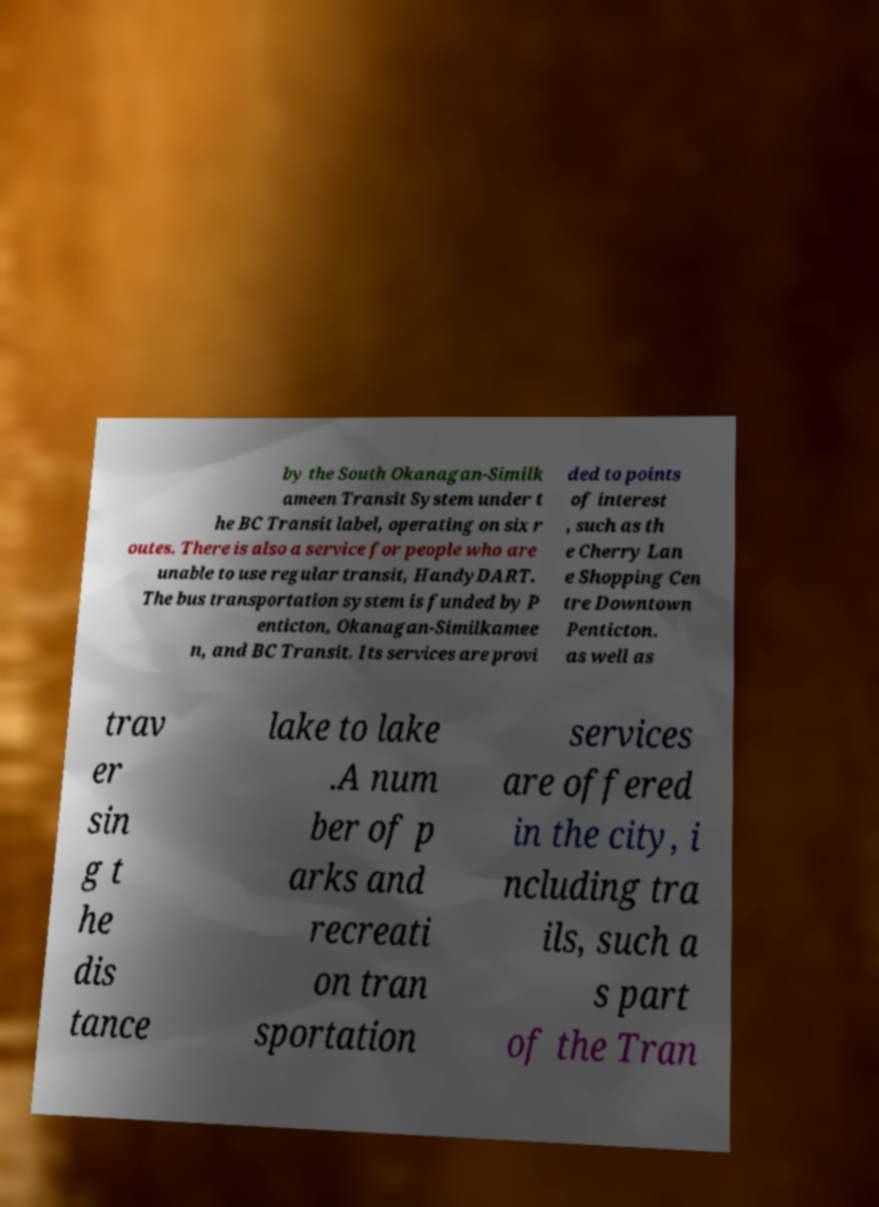Please read and relay the text visible in this image. What does it say? by the South Okanagan-Similk ameen Transit System under t he BC Transit label, operating on six r outes. There is also a service for people who are unable to use regular transit, HandyDART. The bus transportation system is funded by P enticton, Okanagan-Similkamee n, and BC Transit. Its services are provi ded to points of interest , such as th e Cherry Lan e Shopping Cen tre Downtown Penticton. as well as trav er sin g t he dis tance lake to lake .A num ber of p arks and recreati on tran sportation services are offered in the city, i ncluding tra ils, such a s part of the Tran 